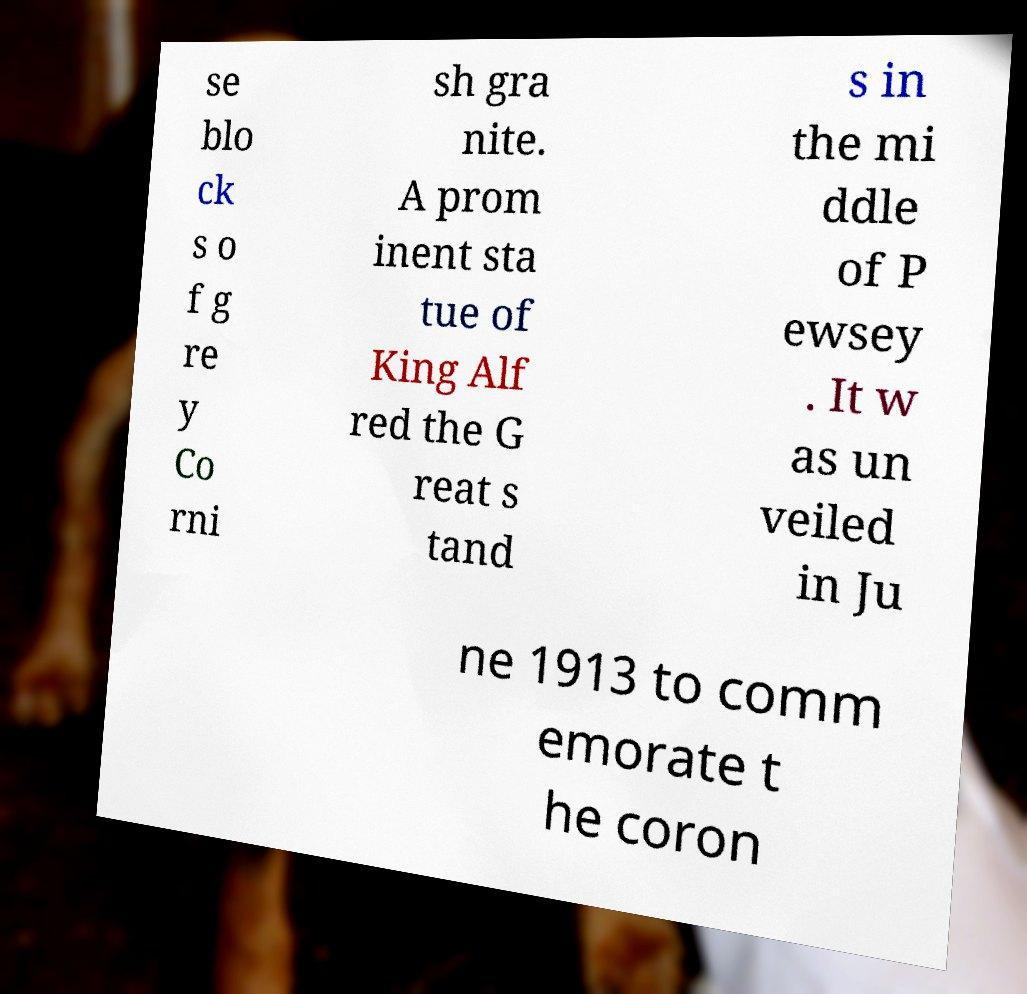Please read and relay the text visible in this image. What does it say? se blo ck s o f g re y Co rni sh gra nite. A prom inent sta tue of King Alf red the G reat s tand s in the mi ddle of P ewsey . It w as un veiled in Ju ne 1913 to comm emorate t he coron 